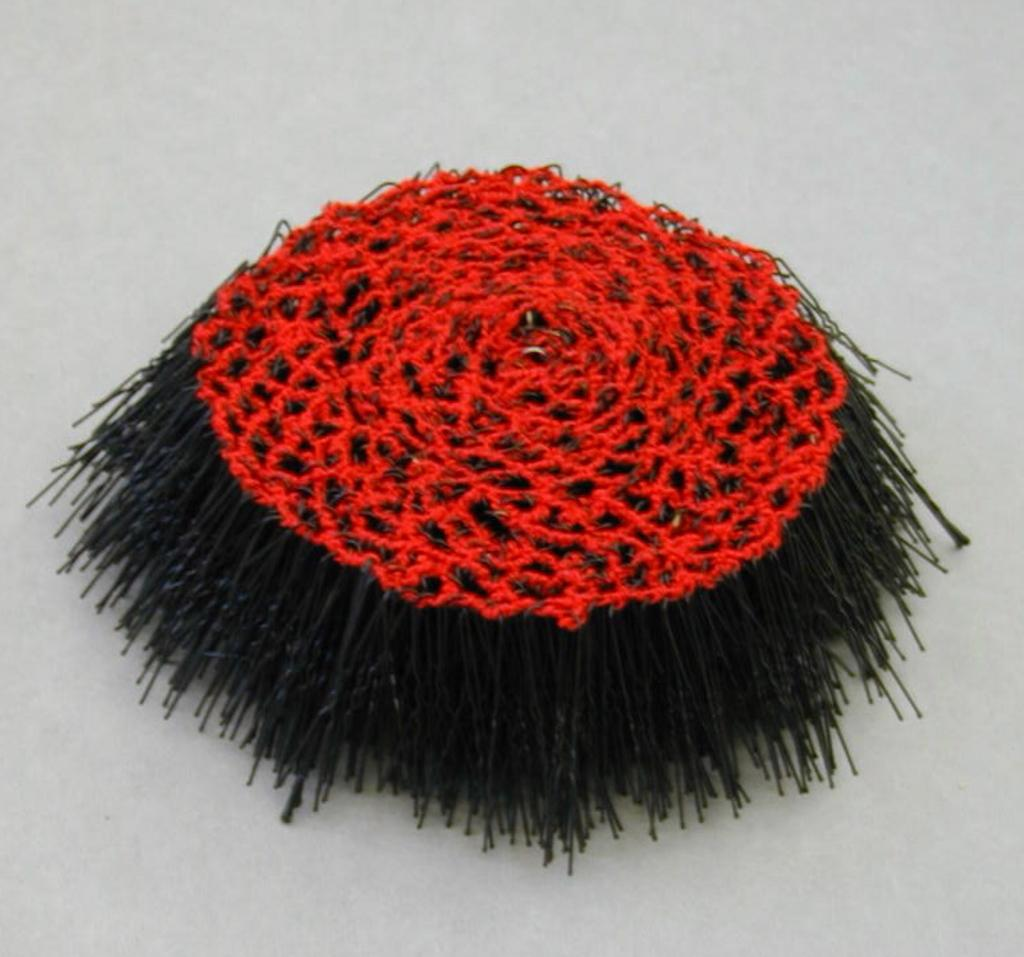What can be seen in the image? There is an object in the image. Can you describe the colors of the object? The object is black and red in color. What type of protest is taking place in the image? There is no protest present in the image; it only features an object that is black and red in color. What kind of structure is depicted in the image? There is no structure depicted in the image; it only features an object that is black and red in color. 